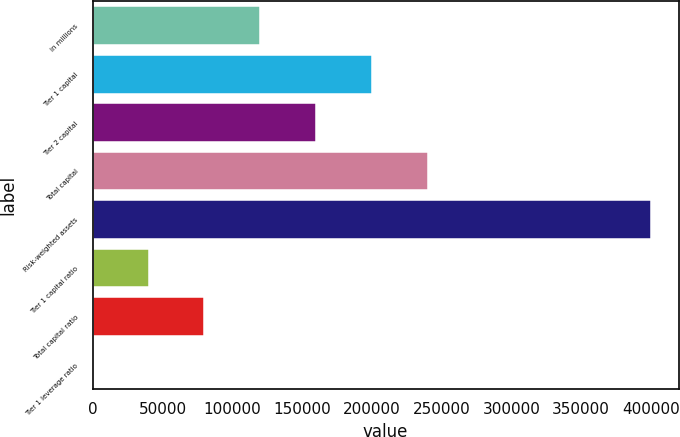<chart> <loc_0><loc_0><loc_500><loc_500><bar_chart><fcel>in millions<fcel>Tier 1 capital<fcel>Tier 2 capital<fcel>Total capital<fcel>Risk-weighted assets<fcel>Tier 1 capital ratio<fcel>Total capital ratio<fcel>Tier 1 leverage ratio<nl><fcel>119984<fcel>199968<fcel>159976<fcel>239960<fcel>399928<fcel>39999.4<fcel>79991.4<fcel>7.3<nl></chart> 